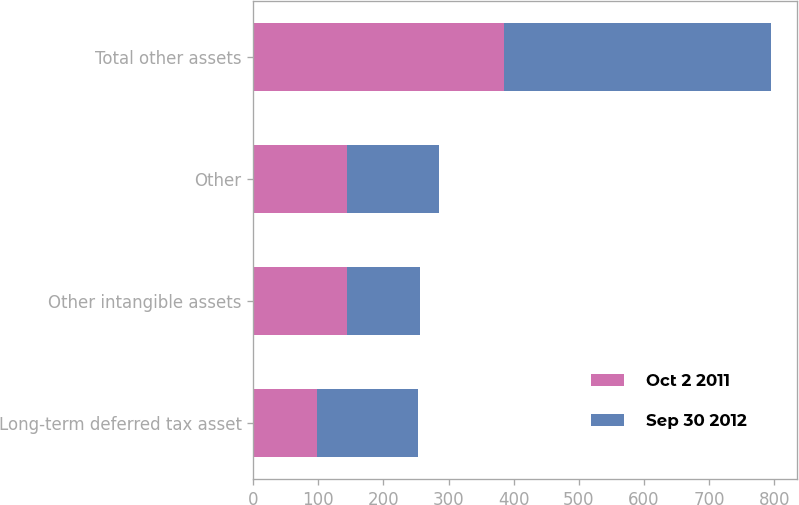Convert chart to OTSL. <chart><loc_0><loc_0><loc_500><loc_500><stacked_bar_chart><ecel><fcel>Long-term deferred tax asset<fcel>Other intangible assets<fcel>Other<fcel>Total other assets<nl><fcel>Oct 2 2011<fcel>97.3<fcel>143.7<fcel>144.7<fcel>385.7<nl><fcel>Sep 30 2012<fcel>156.3<fcel>111.9<fcel>141.4<fcel>409.6<nl></chart> 